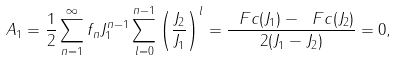<formula> <loc_0><loc_0><loc_500><loc_500>A _ { 1 } = \frac { 1 } { 2 } \sum _ { n = 1 } ^ { \infty } f _ { n } J _ { 1 } ^ { n - 1 } \sum _ { l = 0 } ^ { n - 1 } \left ( \frac { J _ { 2 } } { J _ { 1 } } \right ) ^ { l } = \frac { \ F c ( J _ { 1 } ) - \ F c ( J _ { 2 } ) } { 2 ( J _ { 1 } - J _ { 2 } ) } = 0 ,</formula> 